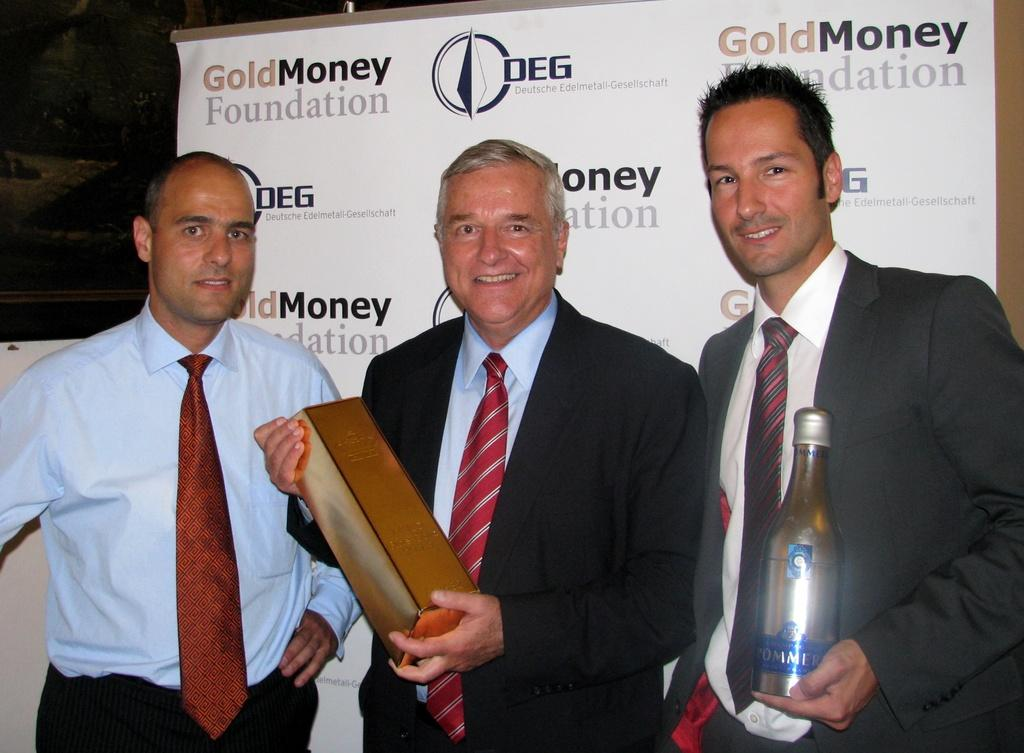How many people are in the image? There are three persons standing in the image. What are the expressions on the faces of the persons? The persons are smiling. What are the persons holding in their hands? The persons are holding bottles. What can be seen in the background of the image? There is a banner visible in the background of the image. What type of advice is the creature giving to the persons in the image? There is no creature present in the image, so it cannot provide any advice. 